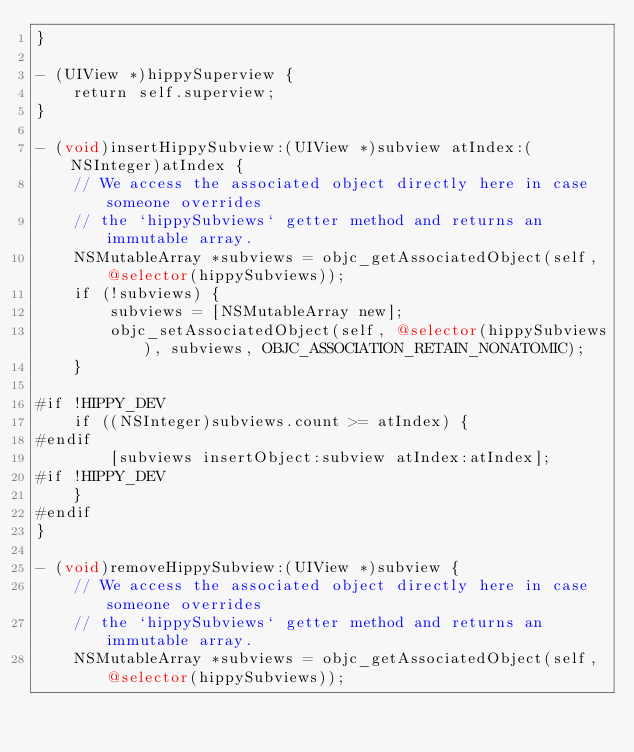<code> <loc_0><loc_0><loc_500><loc_500><_ObjectiveC_>}

- (UIView *)hippySuperview {
    return self.superview;
}

- (void)insertHippySubview:(UIView *)subview atIndex:(NSInteger)atIndex {
    // We access the associated object directly here in case someone overrides
    // the `hippySubviews` getter method and returns an immutable array.
    NSMutableArray *subviews = objc_getAssociatedObject(self, @selector(hippySubviews));
    if (!subviews) {
        subviews = [NSMutableArray new];
        objc_setAssociatedObject(self, @selector(hippySubviews), subviews, OBJC_ASSOCIATION_RETAIN_NONATOMIC);
    }

#if !HIPPY_DEV
    if ((NSInteger)subviews.count >= atIndex) {
#endif
        [subviews insertObject:subview atIndex:atIndex];
#if !HIPPY_DEV
    }
#endif
}

- (void)removeHippySubview:(UIView *)subview {
    // We access the associated object directly here in case someone overrides
    // the `hippySubviews` getter method and returns an immutable array.
    NSMutableArray *subviews = objc_getAssociatedObject(self, @selector(hippySubviews));</code> 